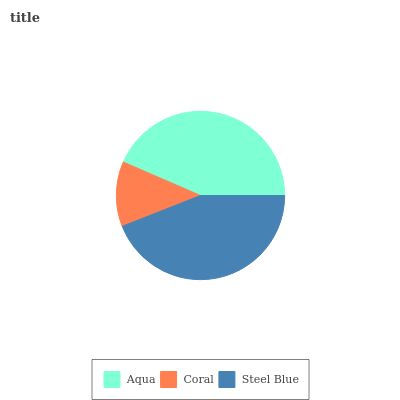Is Coral the minimum?
Answer yes or no. Yes. Is Steel Blue the maximum?
Answer yes or no. Yes. Is Steel Blue the minimum?
Answer yes or no. No. Is Coral the maximum?
Answer yes or no. No. Is Steel Blue greater than Coral?
Answer yes or no. Yes. Is Coral less than Steel Blue?
Answer yes or no. Yes. Is Coral greater than Steel Blue?
Answer yes or no. No. Is Steel Blue less than Coral?
Answer yes or no. No. Is Aqua the high median?
Answer yes or no. Yes. Is Aqua the low median?
Answer yes or no. Yes. Is Steel Blue the high median?
Answer yes or no. No. Is Coral the low median?
Answer yes or no. No. 